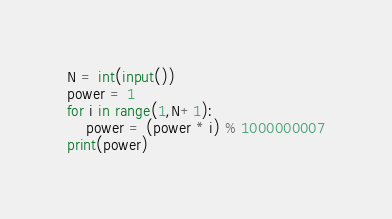<code> <loc_0><loc_0><loc_500><loc_500><_Python_>N = int(input())
power = 1
for i in range(1,N+1):
    power = (power * i) % 1000000007
print(power)
</code> 